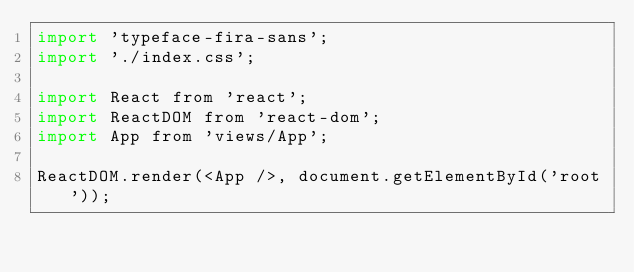Convert code to text. <code><loc_0><loc_0><loc_500><loc_500><_JavaScript_>import 'typeface-fira-sans';
import './index.css';

import React from 'react';
import ReactDOM from 'react-dom';
import App from 'views/App';

ReactDOM.render(<App />, document.getElementById('root'));
</code> 